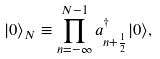<formula> <loc_0><loc_0><loc_500><loc_500>| 0 \rangle _ { N } \equiv \prod _ { n = - \infty } ^ { N - 1 } a _ { n + \frac { 1 } { 2 } } ^ { \dagger } | 0 \rangle ,</formula> 